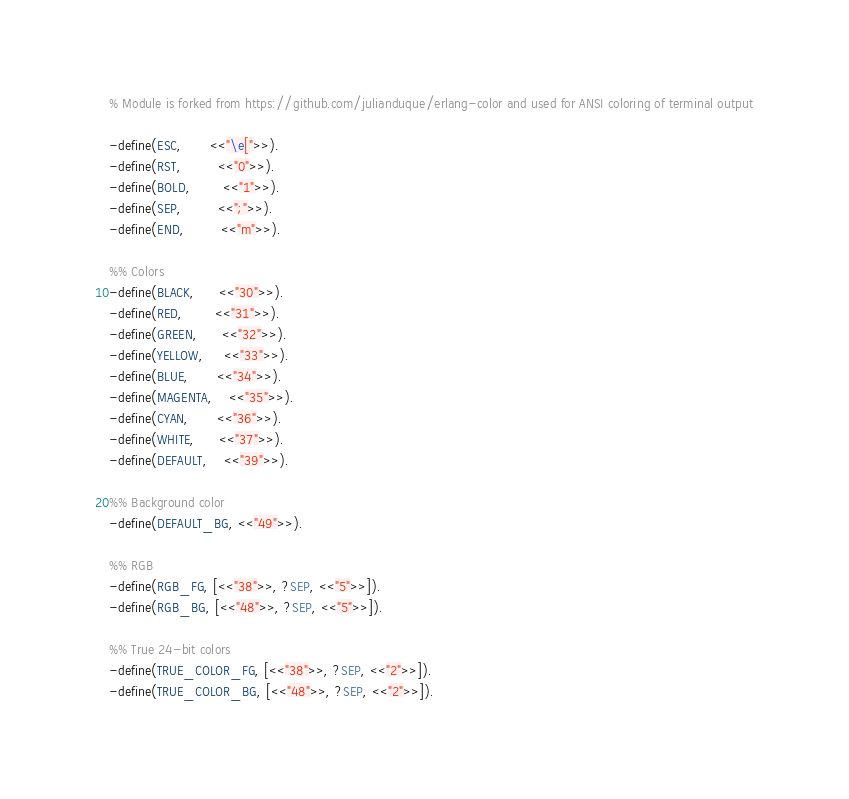<code> <loc_0><loc_0><loc_500><loc_500><_Erlang_>% Module is forked from https://github.com/julianduque/erlang-color and used for ANSI coloring of terminal output

-define(ESC,       <<"\e[">>).
-define(RST,         <<"0">>).
-define(BOLD,        <<"1">>).
-define(SEP,         <<";">>).
-define(END,         <<"m">>).

%% Colors
-define(BLACK,      <<"30">>).
-define(RED,        <<"31">>).
-define(GREEN,      <<"32">>).
-define(YELLOW,     <<"33">>).
-define(BLUE,       <<"34">>).
-define(MAGENTA,    <<"35">>).
-define(CYAN,       <<"36">>).
-define(WHITE,      <<"37">>).
-define(DEFAULT,    <<"39">>).

%% Background color
-define(DEFAULT_BG, <<"49">>).

%% RGB
-define(RGB_FG, [<<"38">>, ?SEP, <<"5">>]).
-define(RGB_BG, [<<"48">>, ?SEP, <<"5">>]).

%% True 24-bit colors
-define(TRUE_COLOR_FG, [<<"38">>, ?SEP, <<"2">>]).
-define(TRUE_COLOR_BG, [<<"48">>, ?SEP, <<"2">>]).</code> 